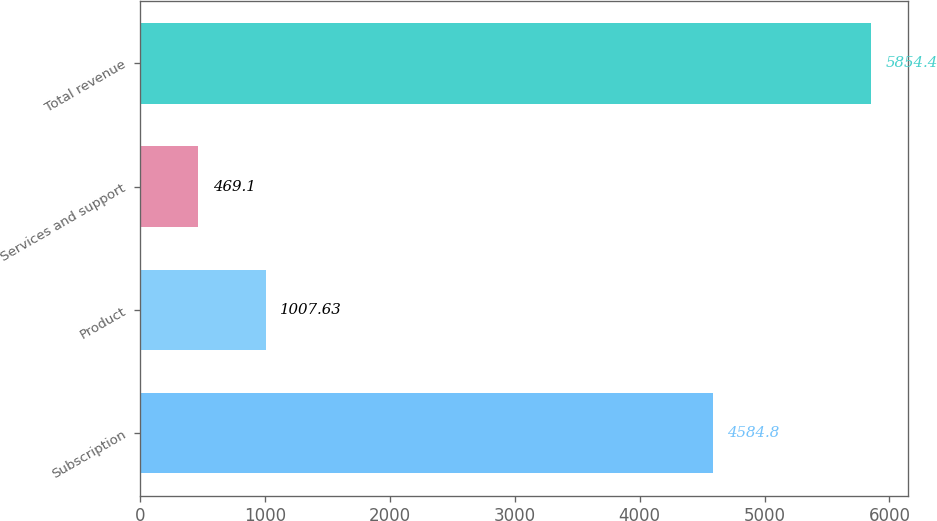Convert chart. <chart><loc_0><loc_0><loc_500><loc_500><bar_chart><fcel>Subscription<fcel>Product<fcel>Services and support<fcel>Total revenue<nl><fcel>4584.8<fcel>1007.63<fcel>469.1<fcel>5854.4<nl></chart> 